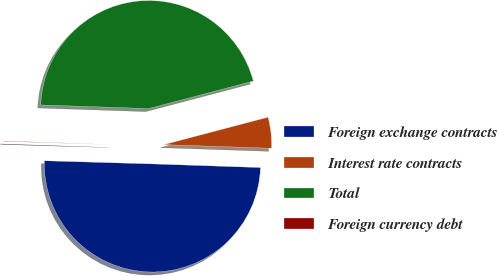<chart> <loc_0><loc_0><loc_500><loc_500><pie_chart><fcel>Foreign exchange contracts<fcel>Interest rate contracts<fcel>Total<fcel>Foreign currency debt<nl><fcel>49.93%<fcel>4.63%<fcel>45.37%<fcel>0.07%<nl></chart> 